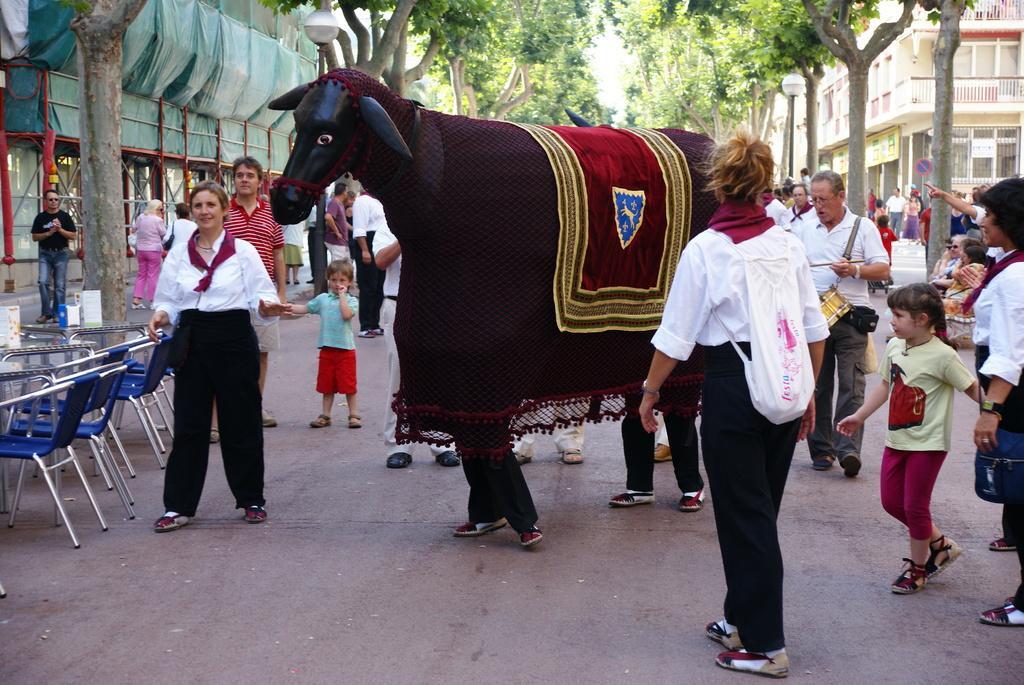Can you describe this image briefly? In this image i can see few man standing on road there is a doll, there are few trees, building and a light pole at left there are few chairs and a table. 